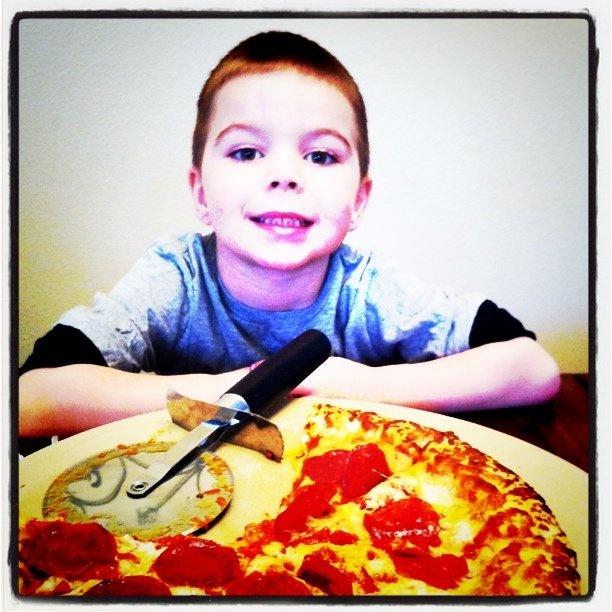Describe the objects in this image and their specific colors. I can see people in white, black, violet, and navy tones, pizza in white, red, brown, and orange tones, and dining table in white, black, maroon, violet, and lightgray tones in this image. 